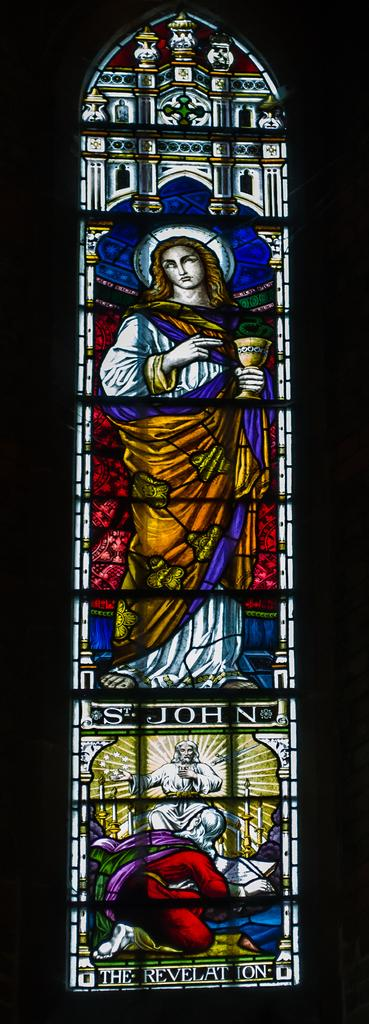Who or what can be seen in the image? There are persons depicted in the image. What else is present in the image besides the persons? There is text present in the image. What type of cheese is being used to create the flesh-like texture in the image? There is no cheese or flesh-like texture present in the image; it only features persons and text. 